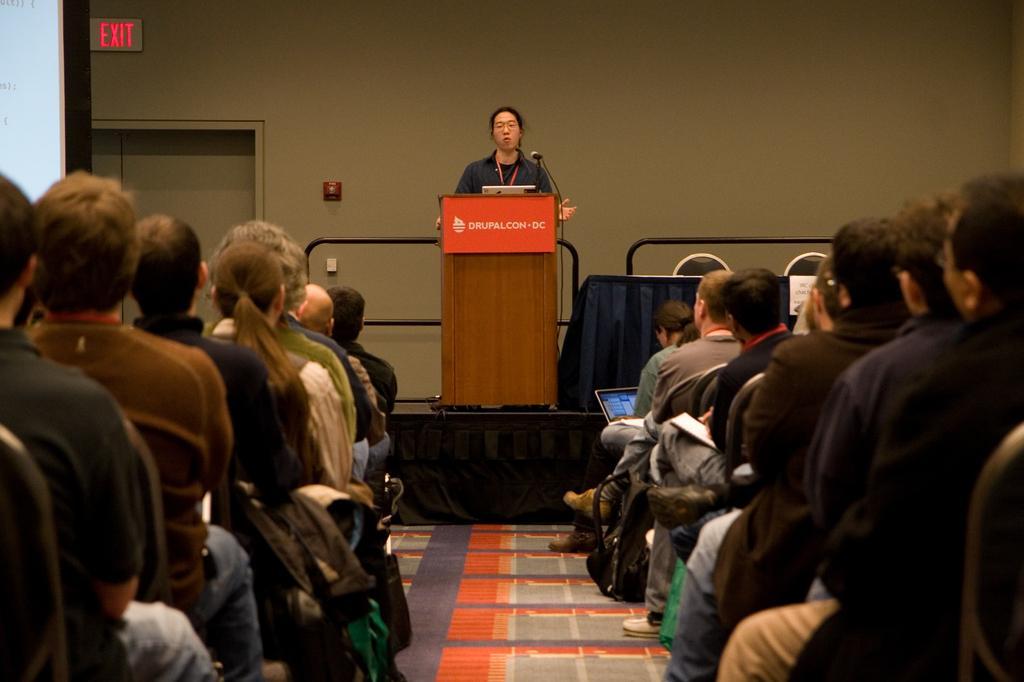Please provide a concise description of this image. In this image we can see many people sitting. In the back there is a person standing. In front of him there is a podium with a board. On that something is written. Also there is a mic. In the background there is a wall with an exit board. Also there is door. And there are railings. And there is a table. And there are chairs. And there is a person holding a laptop. Near to him there is a bag. 